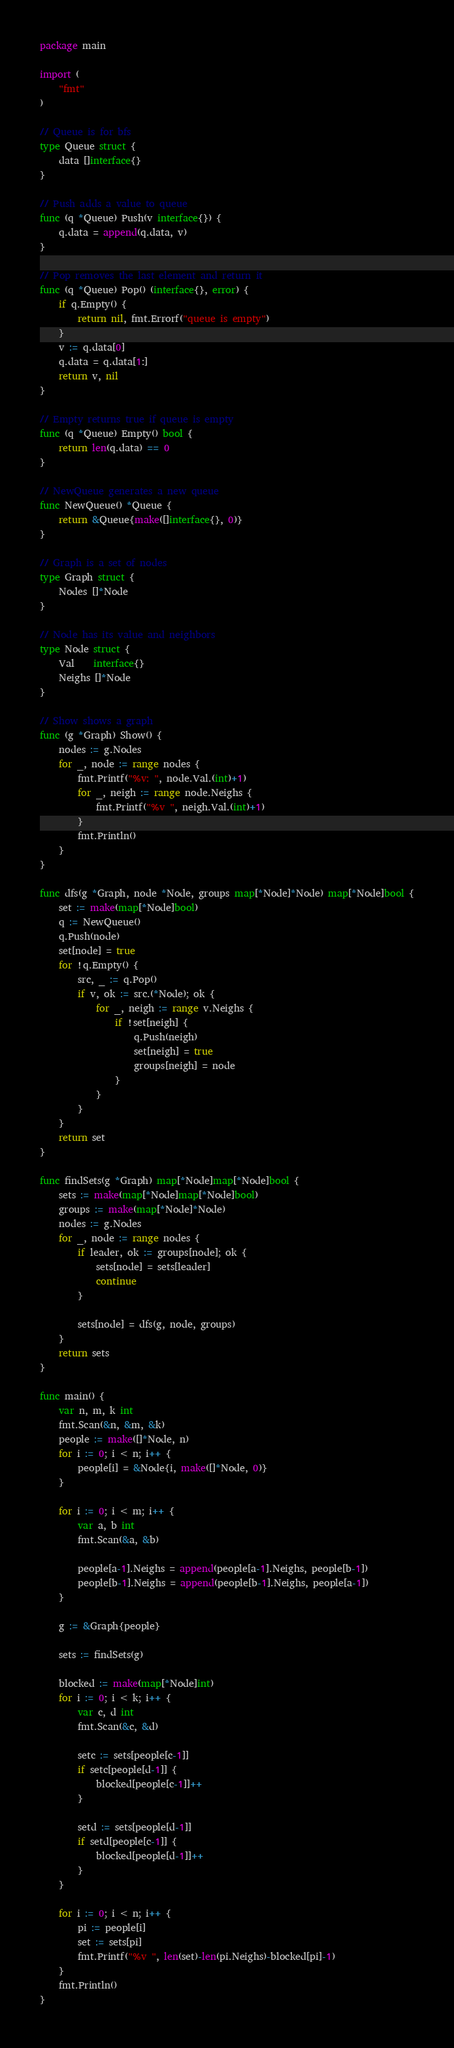<code> <loc_0><loc_0><loc_500><loc_500><_Go_>package main

import (
	"fmt"
)

// Queue is for bfs
type Queue struct {
	data []interface{}
}

// Push adds a value to queue
func (q *Queue) Push(v interface{}) {
	q.data = append(q.data, v)
}

// Pop removes the last element and return it
func (q *Queue) Pop() (interface{}, error) {
	if q.Empty() {
		return nil, fmt.Errorf("queue is empty")
	}
	v := q.data[0]
	q.data = q.data[1:]
	return v, nil
}

// Empty returns true if queue is empty
func (q *Queue) Empty() bool {
	return len(q.data) == 0
}

// NewQueue generates a new queue
func NewQueue() *Queue {
	return &Queue{make([]interface{}, 0)}
}

// Graph is a set of nodes
type Graph struct {
	Nodes []*Node
}

// Node has its value and neighbors
type Node struct {
	Val    interface{}
	Neighs []*Node
}

// Show shows a graph
func (g *Graph) Show() {
	nodes := g.Nodes
	for _, node := range nodes {
		fmt.Printf("%v: ", node.Val.(int)+1)
		for _, neigh := range node.Neighs {
			fmt.Printf("%v ", neigh.Val.(int)+1)
		}
		fmt.Println()
	}
}

func dfs(g *Graph, node *Node, groups map[*Node]*Node) map[*Node]bool {
	set := make(map[*Node]bool)
	q := NewQueue()
	q.Push(node)
	set[node] = true
	for !q.Empty() {
		src, _ := q.Pop()
		if v, ok := src.(*Node); ok {
			for _, neigh := range v.Neighs {
				if !set[neigh] {
					q.Push(neigh)
					set[neigh] = true
					groups[neigh] = node
				}
			}
		}
	}
	return set
}

func findSets(g *Graph) map[*Node]map[*Node]bool {
	sets := make(map[*Node]map[*Node]bool)
	groups := make(map[*Node]*Node)
	nodes := g.Nodes
	for _, node := range nodes {
		if leader, ok := groups[node]; ok {
			sets[node] = sets[leader]
			continue
		}

		sets[node] = dfs(g, node, groups)
	}
	return sets
}

func main() {
	var n, m, k int
	fmt.Scan(&n, &m, &k)
	people := make([]*Node, n)
	for i := 0; i < n; i++ {
		people[i] = &Node{i, make([]*Node, 0)}
	}

	for i := 0; i < m; i++ {
		var a, b int
		fmt.Scan(&a, &b)

		people[a-1].Neighs = append(people[a-1].Neighs, people[b-1])
		people[b-1].Neighs = append(people[b-1].Neighs, people[a-1])
	}

	g := &Graph{people}

	sets := findSets(g)

	blocked := make(map[*Node]int)
	for i := 0; i < k; i++ {
		var c, d int
		fmt.Scan(&c, &d)

		setc := sets[people[c-1]]
		if setc[people[d-1]] {
			blocked[people[c-1]]++
		}

		setd := sets[people[d-1]]
		if setd[people[c-1]] {
			blocked[people[d-1]]++
		}
	}

	for i := 0; i < n; i++ {
		pi := people[i]
		set := sets[pi]
		fmt.Printf("%v ", len(set)-len(pi.Neighs)-blocked[pi]-1)
	}
	fmt.Println()
}
</code> 